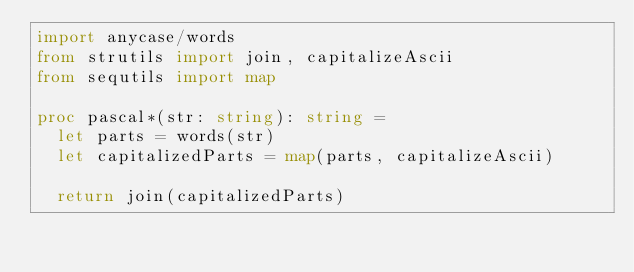Convert code to text. <code><loc_0><loc_0><loc_500><loc_500><_Nim_>import anycase/words
from strutils import join, capitalizeAscii
from sequtils import map

proc pascal*(str: string): string =
  let parts = words(str)
  let capitalizedParts = map(parts, capitalizeAscii)

  return join(capitalizedParts)
</code> 